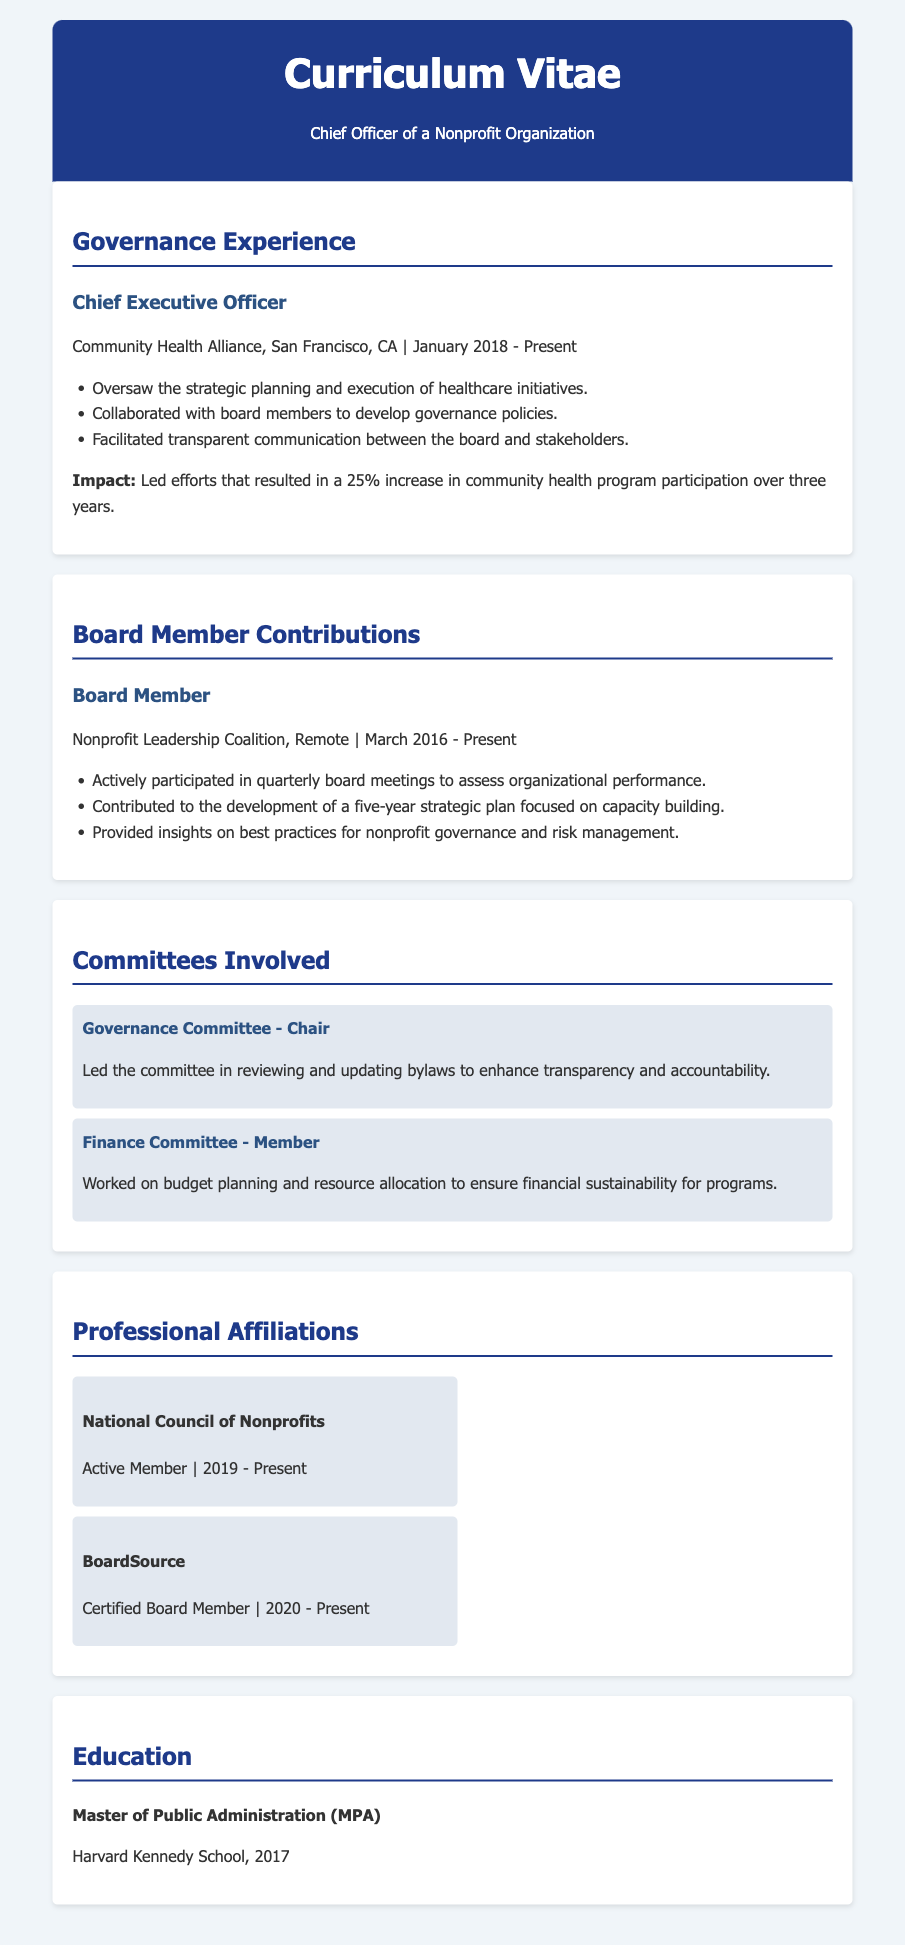What is the current position of the individual? The document states that the individual holds the position of Chief Executive Officer.
Answer: Chief Executive Officer Which organization is mentioned in the Governance Experience section? The organization listed in the Governance Experience section is Community Health Alliance.
Answer: Community Health Alliance What significant impact did the individual achieve in their role as CEO? The document mentions a specific impact of a 25% increase in community health program participation.
Answer: 25% increase When did the individual start serving on the Board of the Nonprofit Leadership Coalition? The document states that the individual began in March 2016.
Answer: March 2016 What role does the individual hold in the Governance Committee? The document indicates that the individual is the Chair of the Governance Committee.
Answer: Chair What is the focus of the five-year strategic plan developed by the Nonprofit Leadership Coalition? The focus mentioned in the document is on capacity building.
Answer: Capacity building Which organization has recognized the individual as a Certified Board Member? The document specifies that BoardSource has recognized this status.
Answer: BoardSource How long has the individual been an active member of the National Council of Nonprofits? The document indicates that the individual has been an active member since 2019.
Answer: Since 2019 